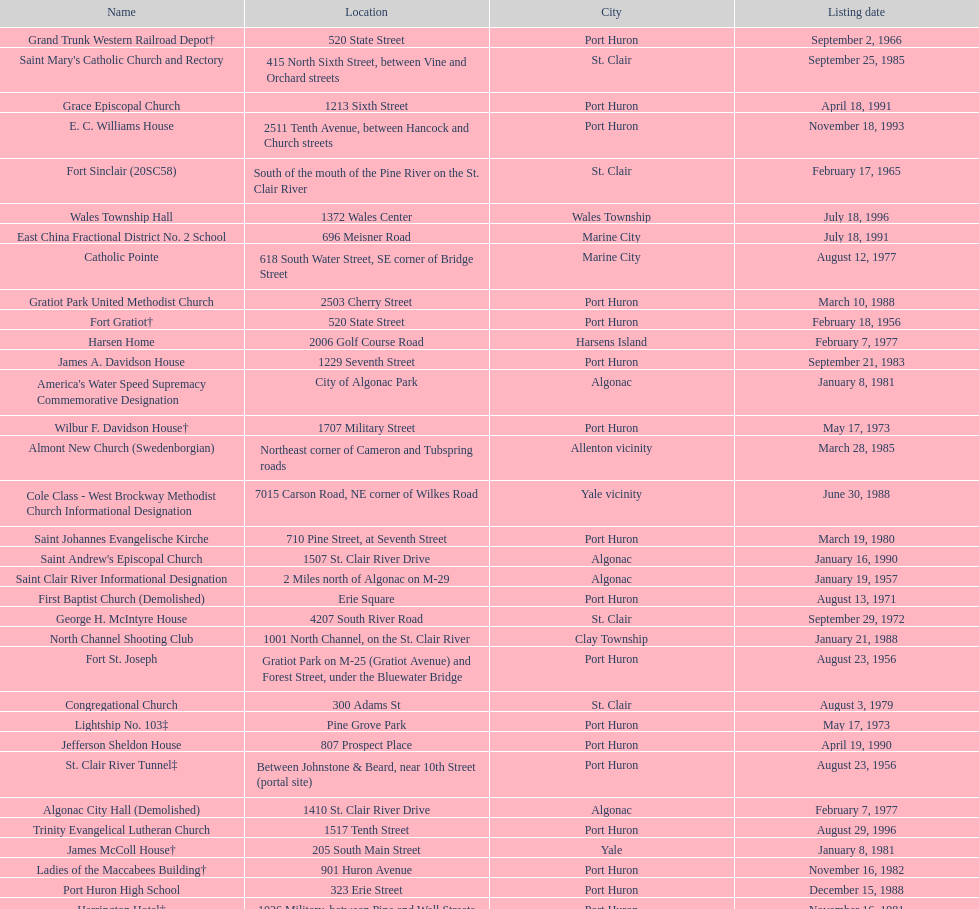Which city is home to the greatest number of historic sites, existing or demolished? Port Huron. 